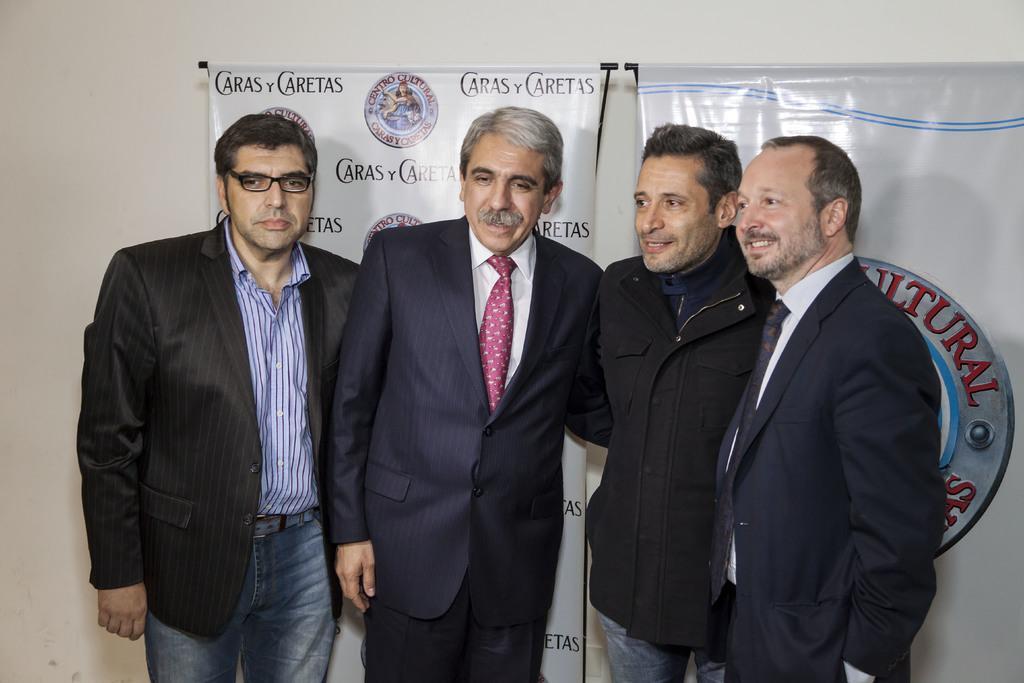Please provide a concise description of this image. In this picture I can see four persons standing, there are banners, and in the background there is a wall. 